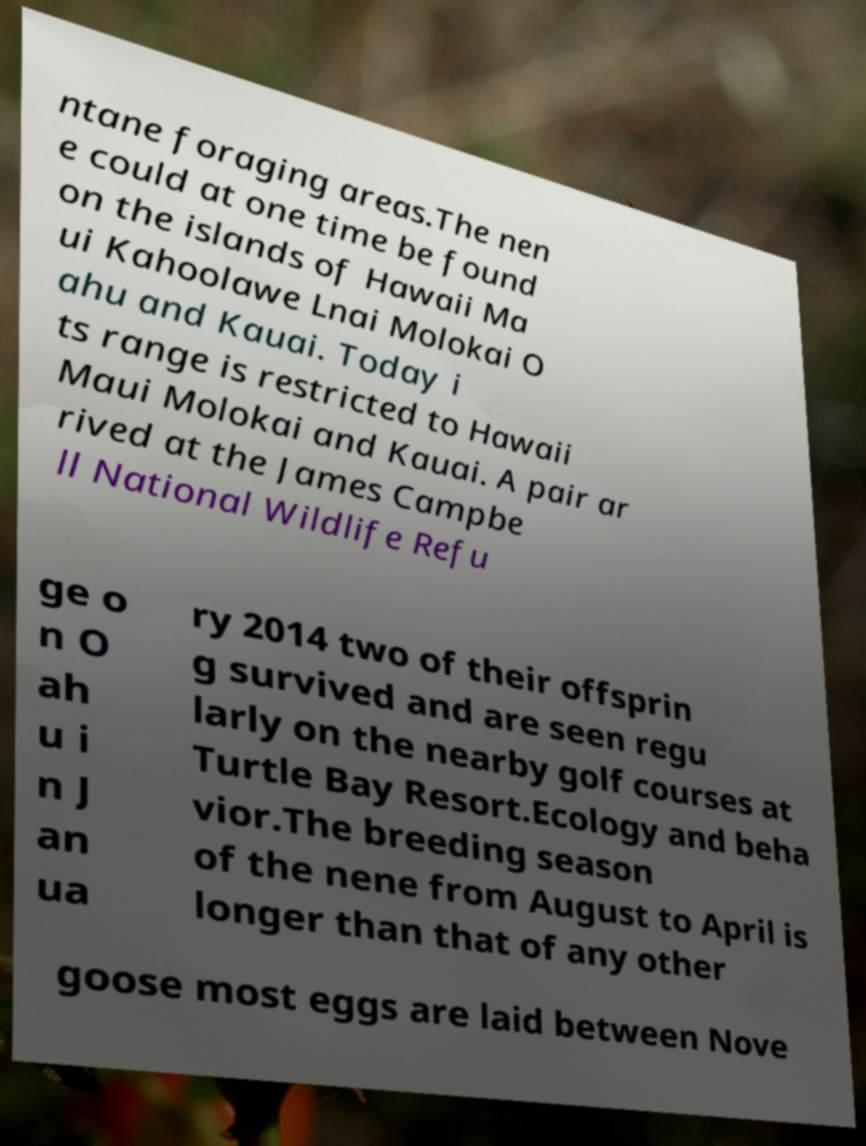Could you extract and type out the text from this image? ntane foraging areas.The nen e could at one time be found on the islands of Hawaii Ma ui Kahoolawe Lnai Molokai O ahu and Kauai. Today i ts range is restricted to Hawaii Maui Molokai and Kauai. A pair ar rived at the James Campbe ll National Wildlife Refu ge o n O ah u i n J an ua ry 2014 two of their offsprin g survived and are seen regu larly on the nearby golf courses at Turtle Bay Resort.Ecology and beha vior.The breeding season of the nene from August to April is longer than that of any other goose most eggs are laid between Nove 